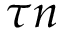<formula> <loc_0><loc_0><loc_500><loc_500>\tau n</formula> 